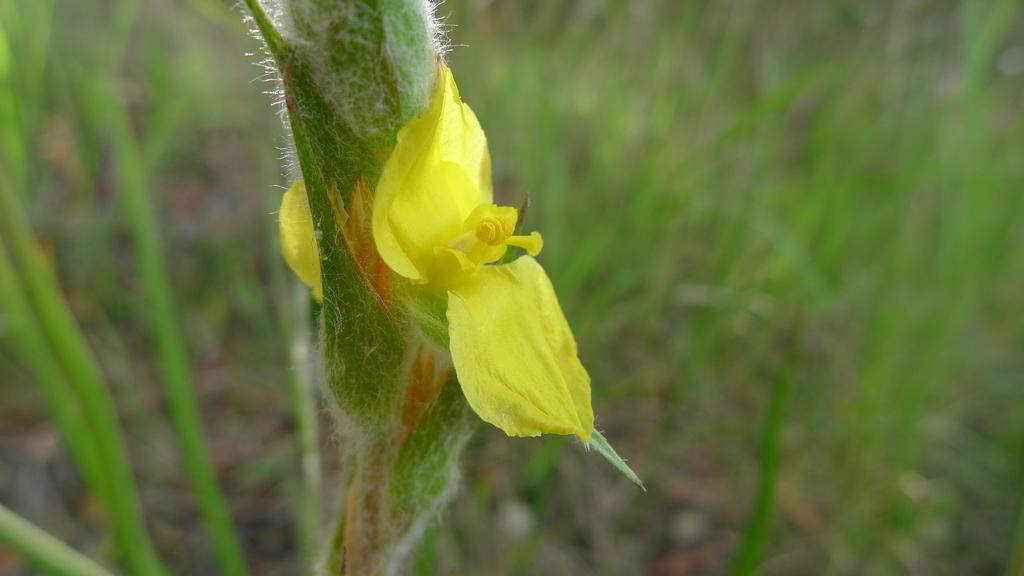What type of flower is in the image? There is a yellow color flower in the image. Where is the flower located in the image? The flower is in the middle of the image. What can be seen in the background of the image? There is grass in the background of the image. How does the flower increase in size during the bath in the image? There is no bath or increase in size mentioned in the image; it simply shows a yellow color flower in the middle of the image. 